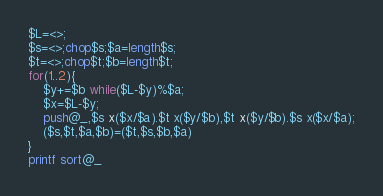<code> <loc_0><loc_0><loc_500><loc_500><_Perl_>$L=<>;
$s=<>;chop$s;$a=length$s;
$t=<>;chop$t;$b=length$t;
for(1..2){
	$y+=$b while($L-$y)%$a;
	$x=$L-$y;
	push@_,$s x($x/$a).$t x($y/$b),$t x($y/$b).$s x($x/$a);
	($s,$t,$a,$b)=($t,$s,$b,$a)
}
printf sort@_
</code> 